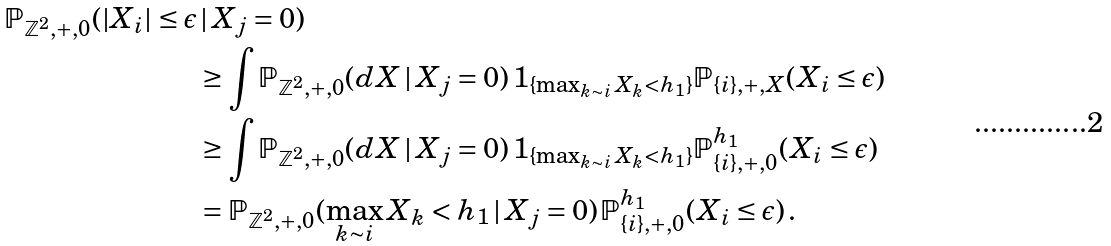<formula> <loc_0><loc_0><loc_500><loc_500>\mathbb { P } _ { \mathbb { Z } ^ { 2 } , + , 0 } ( | X _ { i } | \leq \epsilon & \, | \, X _ { j } = 0 ) \\ & \geq \int \mathbb { P } _ { \mathbb { Z } ^ { 2 } , + , 0 } ( d X \, | \, X _ { j } = 0 ) \, 1 _ { \{ \max _ { k \sim i } X _ { k } < h _ { 1 } \} } \mathbb { P } _ { \{ i \} , + , X } ( X _ { i } \leq \epsilon ) \\ & \geq \int \mathbb { P } _ { \mathbb { Z } ^ { 2 } , + , 0 } ( d X \, | \, X _ { j } = 0 ) \, 1 _ { \{ \max _ { k \sim i } X _ { k } < h _ { 1 } \} } \mathbb { P } _ { \{ i \} , + , 0 } ^ { h _ { 1 } } ( X _ { i } \leq \epsilon ) \\ & = \mathbb { P } _ { \mathbb { Z } ^ { 2 } , + , 0 } ( \max _ { k \sim i } X _ { k } < h _ { 1 } \, | \, X _ { j } = 0 ) \, \mathbb { P } _ { \{ i \} , + , 0 } ^ { h _ { 1 } } ( X _ { i } \leq \epsilon ) \, .</formula> 